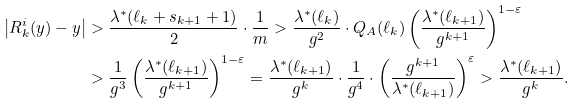<formula> <loc_0><loc_0><loc_500><loc_500>\left | R _ { k } ^ { i } ( y ) - y \right | & > \frac { \lambda ^ { * } ( \ell _ { k } + s _ { k + 1 } + 1 ) } { 2 } \cdot \frac { 1 } { m } > \frac { \lambda ^ { * } ( \ell _ { k } ) } { g ^ { 2 } } \cdot Q _ { A } ( \ell _ { k } ) \left ( \frac { \lambda ^ { * } ( \ell _ { k + 1 } ) } { g ^ { k + 1 } } \right ) ^ { 1 - \varepsilon } \\ & > \frac { 1 } { g ^ { 3 } } \left ( \frac { \lambda ^ { * } ( \ell _ { k + 1 } ) } { g ^ { k + 1 } } \right ) ^ { 1 - \varepsilon } = \frac { \lambda ^ { * } ( \ell _ { k + 1 } ) } { g ^ { k } } \cdot \frac { 1 } { g ^ { 4 } } \cdot \left ( \frac { g ^ { k + 1 } } { \lambda ^ { * } ( \ell _ { k + 1 } ) } \right ) ^ { \varepsilon } > \frac { \lambda ^ { * } ( \ell _ { k + 1 } ) } { g ^ { k } } .</formula> 